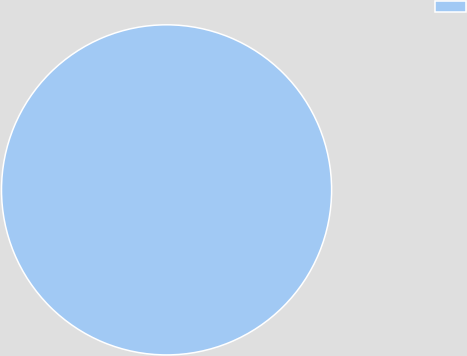Convert chart. <chart><loc_0><loc_0><loc_500><loc_500><pie_chart><ecel><nl><fcel>100.0%<nl></chart> 